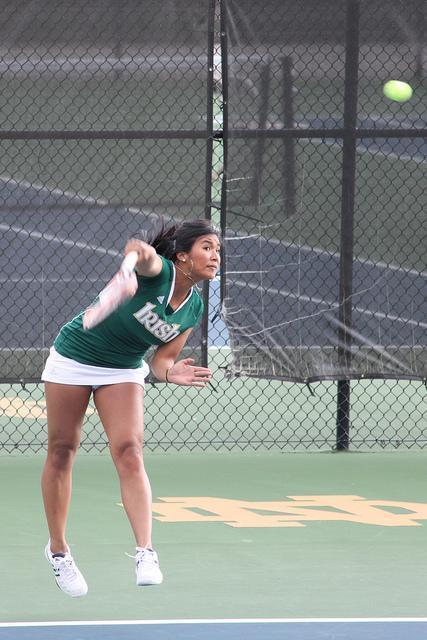How many arched windows are there to the left of the clock tower?
Give a very brief answer. 0. 